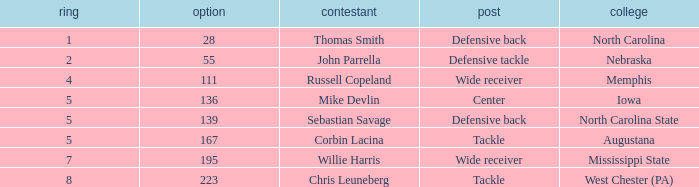What is the sum of Round with a Pick that is 55? 2.0. 